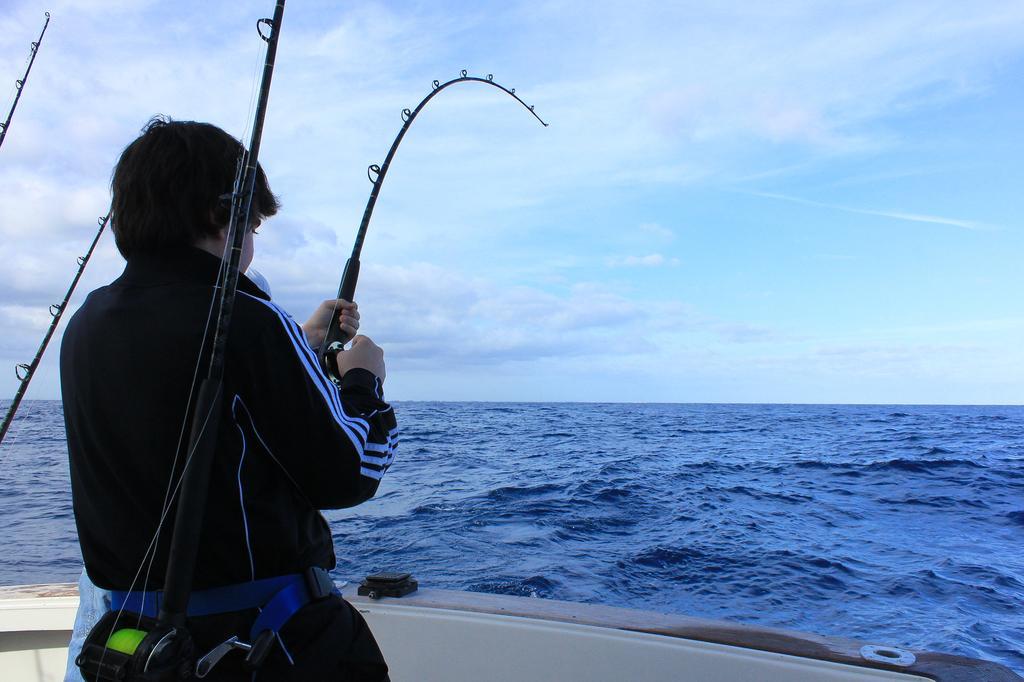Can you describe this image briefly? On the left side of the image we can see a person is standing on the deck of a boat and holding a fishing rod. In the background of the image we can see the water. At the top of the image we can see the clouds in the sky. 